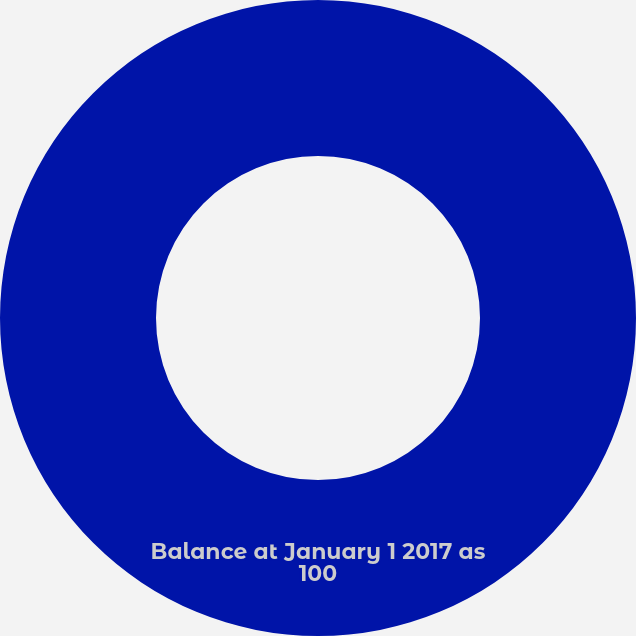<chart> <loc_0><loc_0><loc_500><loc_500><pie_chart><fcel>Balance at January 1 2017 as<nl><fcel>100.0%<nl></chart> 